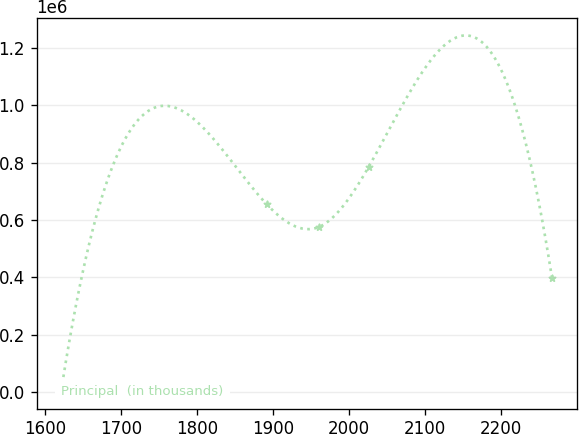<chart> <loc_0><loc_0><loc_500><loc_500><line_chart><ecel><fcel>Principal  (in thousands)<nl><fcel>1621.14<fcel>4569.67<nl><fcel>1891.81<fcel>654462<nl><fcel>1961.16<fcel>576478<nl><fcel>2025.76<fcel>784411<nl><fcel>2267.14<fcel>397544<nl></chart> 